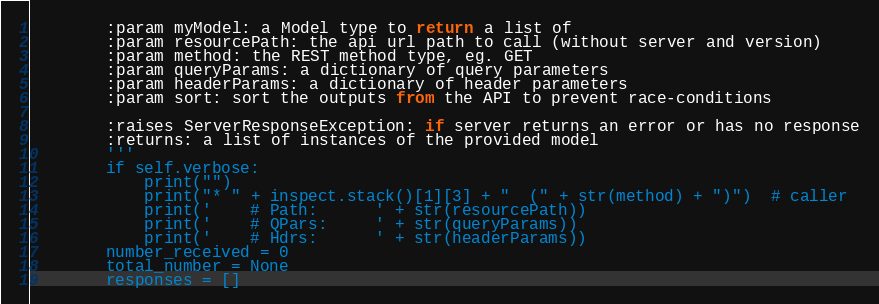Convert code to text. <code><loc_0><loc_0><loc_500><loc_500><_Python_>        :param myModel: a Model type to return a list of
        :param resourcePath: the api url path to call (without server and version)
        :param method: the REST method type, eg. GET
        :param queryParams: a dictionary of query parameters
        :param headerParams: a dictionary of header parameters
        :param sort: sort the outputs from the API to prevent race-conditions

        :raises ServerResponseException: if server returns an error or has no response
        :returns: a list of instances of the provided model
        '''
        if self.verbose:
            print("")
            print("* " + inspect.stack()[1][3] + "  (" + str(method) + ")")  # caller
            print('    # Path:      ' + str(resourcePath))
            print('    # QPars:     ' + str(queryParams))
            print('    # Hdrs:      ' + str(headerParams))
        number_received = 0
        total_number = None
        responses = []</code> 